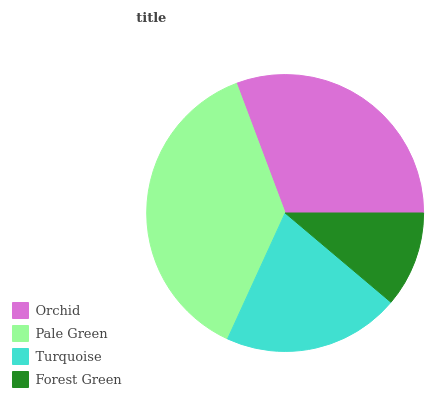Is Forest Green the minimum?
Answer yes or no. Yes. Is Pale Green the maximum?
Answer yes or no. Yes. Is Turquoise the minimum?
Answer yes or no. No. Is Turquoise the maximum?
Answer yes or no. No. Is Pale Green greater than Turquoise?
Answer yes or no. Yes. Is Turquoise less than Pale Green?
Answer yes or no. Yes. Is Turquoise greater than Pale Green?
Answer yes or no. No. Is Pale Green less than Turquoise?
Answer yes or no. No. Is Orchid the high median?
Answer yes or no. Yes. Is Turquoise the low median?
Answer yes or no. Yes. Is Pale Green the high median?
Answer yes or no. No. Is Forest Green the low median?
Answer yes or no. No. 